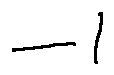Convert formula to latex. <formula><loc_0><loc_0><loc_500><loc_500>- l</formula> 